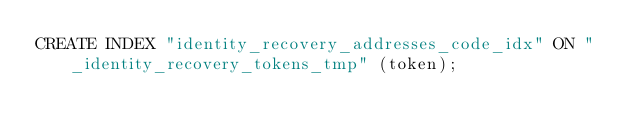Convert code to text. <code><loc_0><loc_0><loc_500><loc_500><_SQL_>CREATE INDEX "identity_recovery_addresses_code_idx" ON "_identity_recovery_tokens_tmp" (token);</code> 